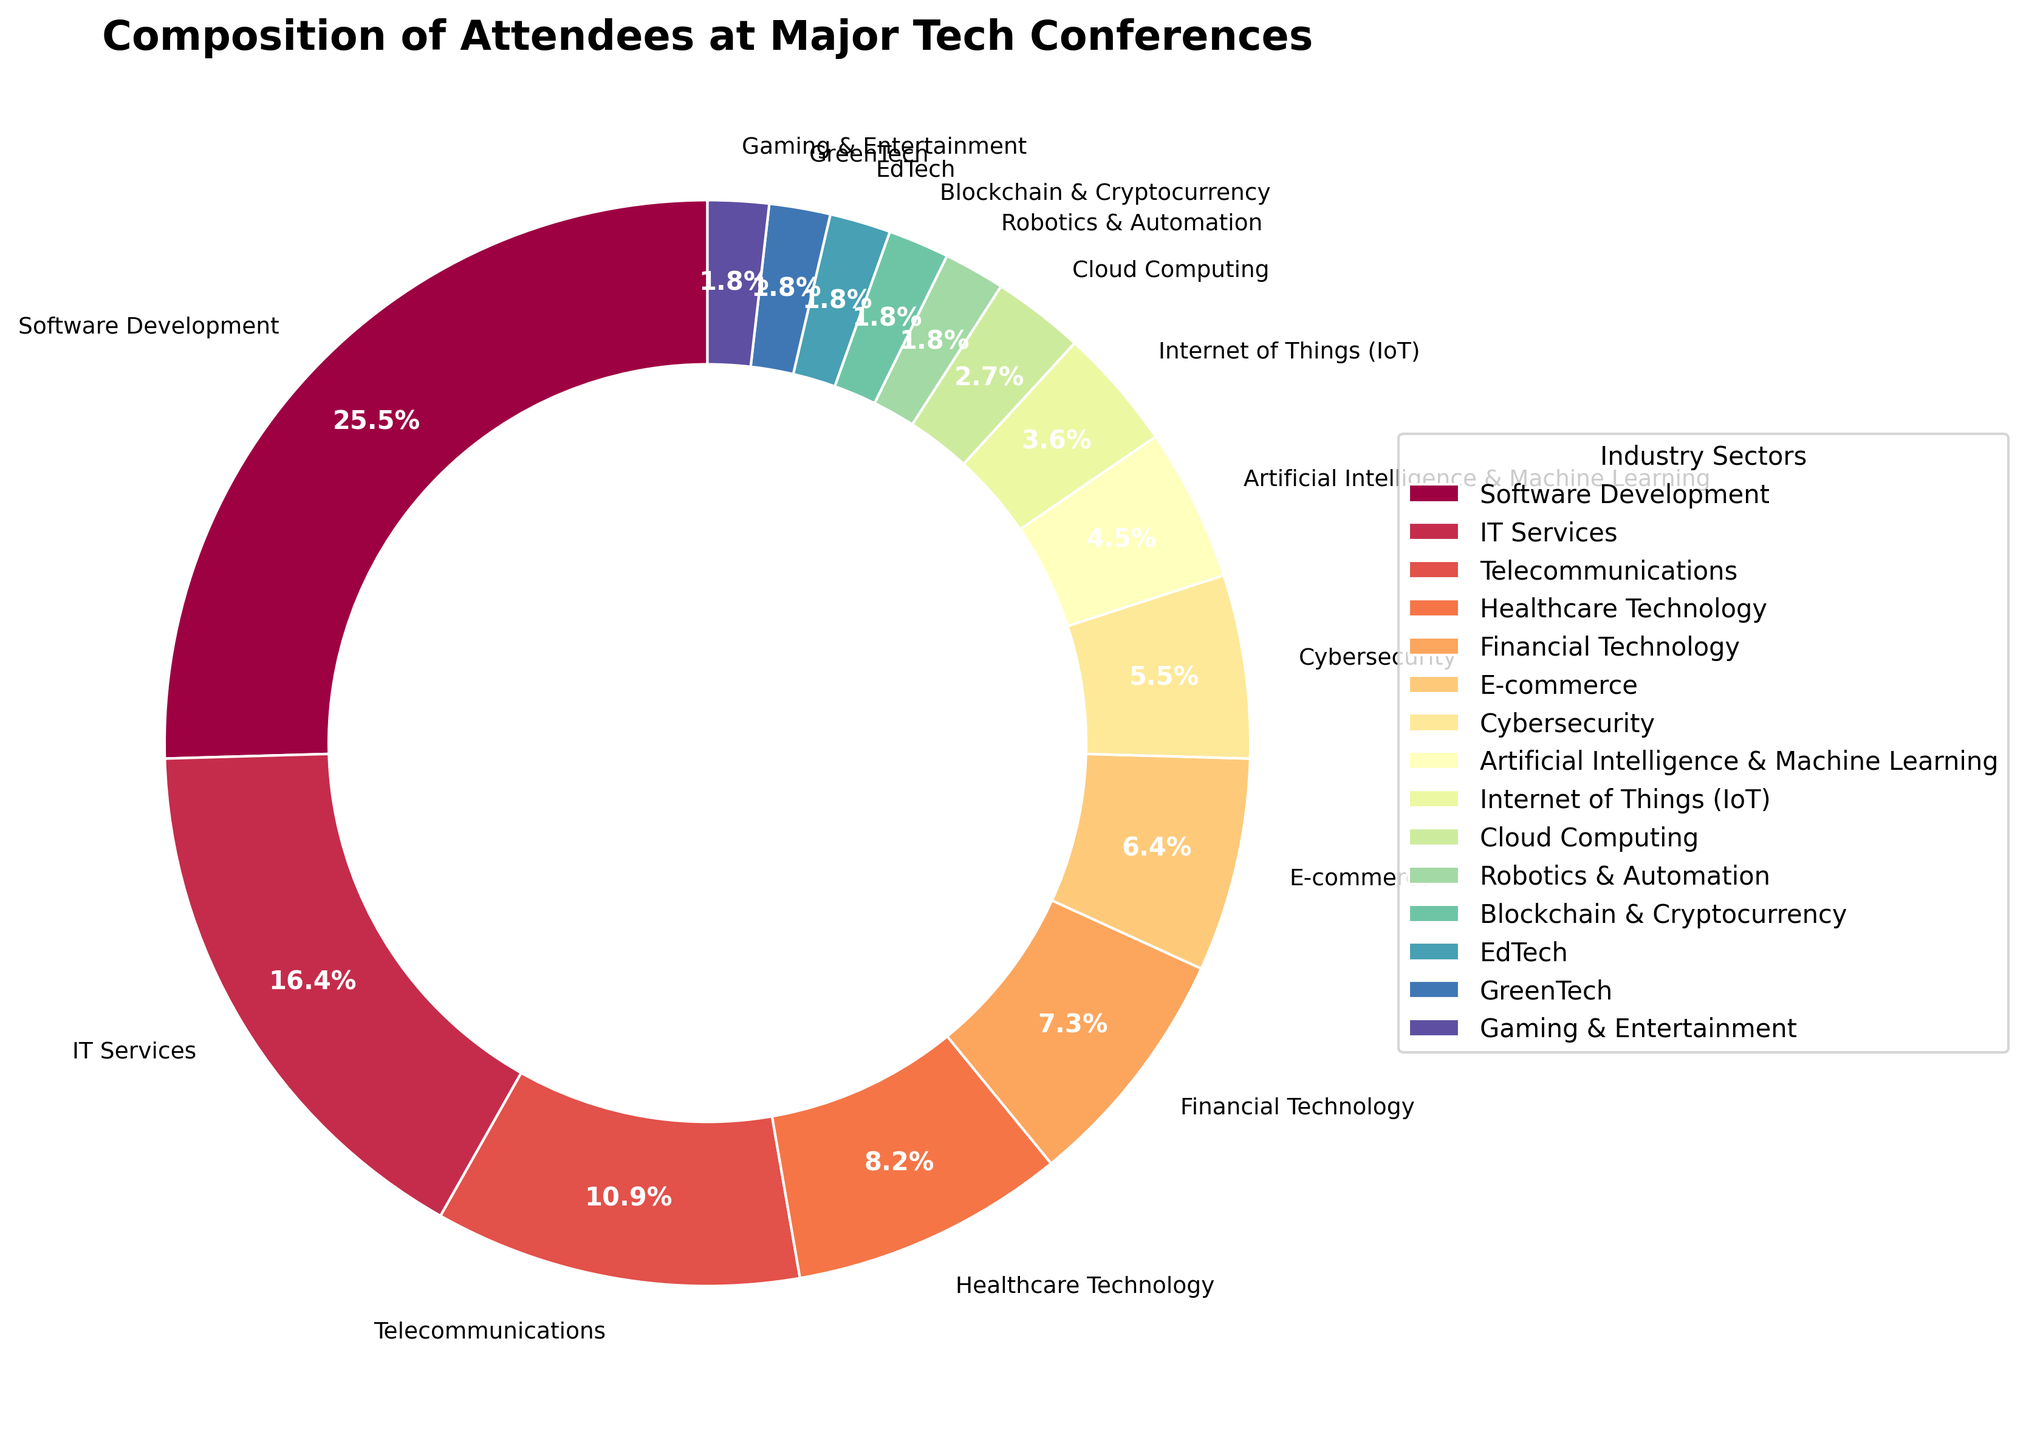Which industry sector has the highest percentage of attendees? To find the industry sector with the highest percentage, look for the largest segment in the pie chart. Software Development has the largest segment, labeled as 28%.
Answer: Software Development How many industry sectors have a percentage of attendees less than 5% each? Identify the sectors with less than 5% by examining the smaller segments labeled with percentages. There are five sectors: Internet of Things (IoT), Cloud Computing, Robotics & Automation, Blockchain & Cryptocurrency, EdTech, GreenTech, and Gaming & Entertainment (each with 4%, 3%, 2%, 2%, 2%, 2%, and 2% respectively).
Answer: 7 What is the combined percentage of attendees from the Financial Technology and Healthcare Technology sectors? Sum the percentages of Financial Technology (8%) and Healthcare Technology (9%) sectors by adding 8 + 9.
Answer: 17% Which sector has a higher percentage of attendees: Telecommunications or Cybersecurity? Compare the percentages of Telecommunications (12%) and Cybersecurity (6%). Telecommunications has the higher percentage.
Answer: Telecommunications Is the percentage of attendees from E-commerce greater than that from Artificial Intelligence & Machine Learning? Compare the percentage for E-commerce (7%) with that for Artificial Intelligence & Machine Learning (5%). E-commerce has the greater percentage.
Answer: Yes What is the difference in percentage between IT Services and Cloud Computing sectors? Subtract the percentage of Cloud Computing (3%) from IT Services (18%). 18 - 3 = 15.
Answer: 15% Which industry sectors make up exactly 2% of the attendees each? Identify sectors with a 2% label. There are five such sectors: Robotics & Automation, Blockchain & Cryptocurrency, EdTech, GreenTech, and Gaming & Entertainment.
Answer: Robotics & Automation, Blockchain & Cryptocurrency, EdTech, GreenTech, Gaming & Entertainment What is the total percentage of attendees represented by the top three industry sectors? Add the percentages of the top three largest sectors: Software Development (28%), IT Services (18%), and Telecommunications (12%). 28 + 18 + 12 = 58.
Answer: 58% Based on the color scheme, which sector is represented by the color nearest to red? Look at the pie chart's color gradients. The sector nearest to red is the one that appears visually closest to a red hue. The gaming & entertainment sector (2%) is closest to red.
Answer: Gaming & Entertainment 